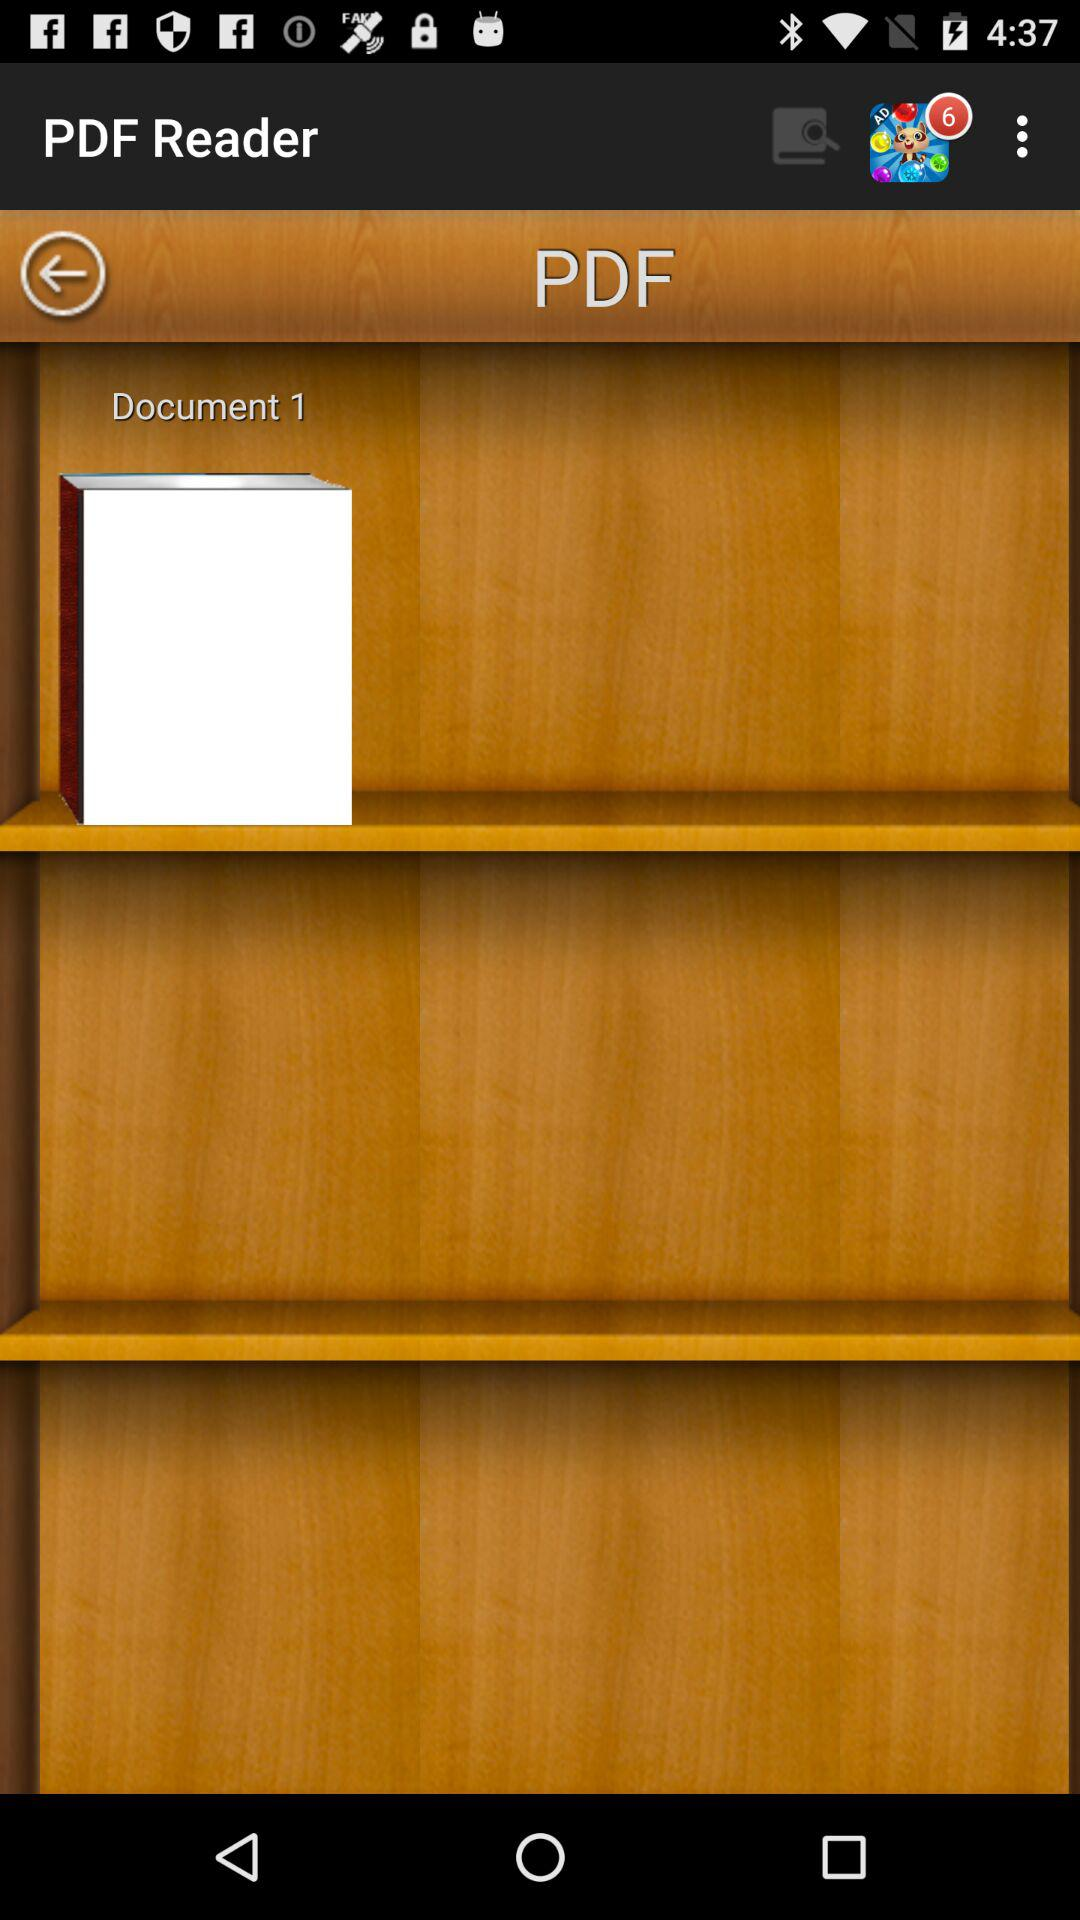What is the name of the PDF available on the screen? The name of the PDF is "Document 1". 